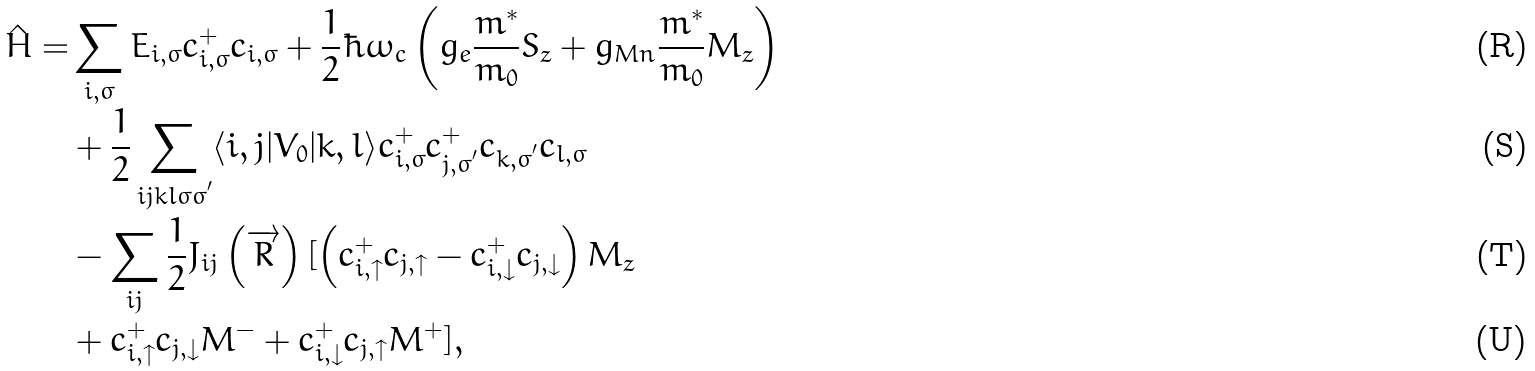Convert formula to latex. <formula><loc_0><loc_0><loc_500><loc_500>\hat { H } = & \sum _ { i , \sigma } E _ { i , \sigma } c _ { i , \sigma } ^ { + } c _ { i , \sigma } + \frac { 1 } { 2 } \hbar { \omega } _ { c } \left ( g _ { e } \frac { m ^ { * } } { m _ { 0 } } { S } _ { z } + g _ { M n } \frac { m ^ { * } } { m _ { 0 } } { M } _ { z } \right ) \\ & + \frac { 1 } { 2 } \sum _ { i j k l \sigma \sigma ^ { ^ { \prime } } } \langle i , j | V _ { 0 } | k , l \rangle c _ { i , \sigma } ^ { + } c _ { j , \sigma ^ { ^ { \prime } } } ^ { + } c _ { k , \sigma ^ { ^ { \prime } } } c _ { l , \sigma } \\ & - \sum _ { i j } \frac { 1 } { 2 } J _ { i j } \left ( \overrightarrow { R } \right ) [ \left ( c _ { i , \uparrow } ^ { + } c _ { j , \uparrow } - c _ { i , \downarrow } ^ { + } c _ { j , \downarrow } \right ) M _ { z } \\ & + c _ { i , \uparrow } ^ { + } c _ { j , \downarrow } M ^ { - } + c _ { i , \downarrow } ^ { + } c _ { j , \uparrow } M ^ { + } ] ,</formula> 